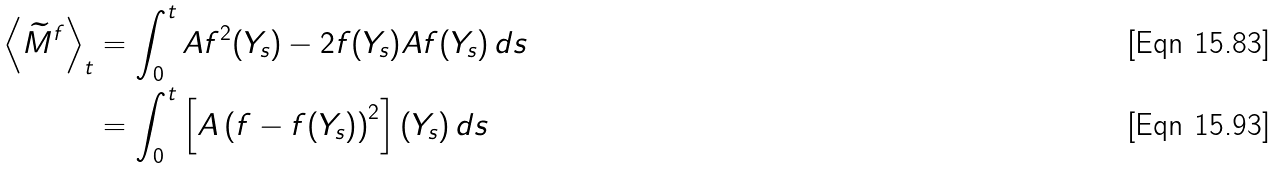<formula> <loc_0><loc_0><loc_500><loc_500>\left < \widetilde { M } ^ { f } \right > _ { t } & = \int _ { 0 } ^ { t } A f ^ { 2 } ( Y _ { s } ) - 2 f ( Y _ { s } ) A f ( Y _ { s } ) \, d s \\ & = \int _ { 0 } ^ { t } \left [ A \left ( f - f ( Y _ { s } ) \right ) ^ { 2 } \right ] ( Y _ { s } ) \, d s</formula> 